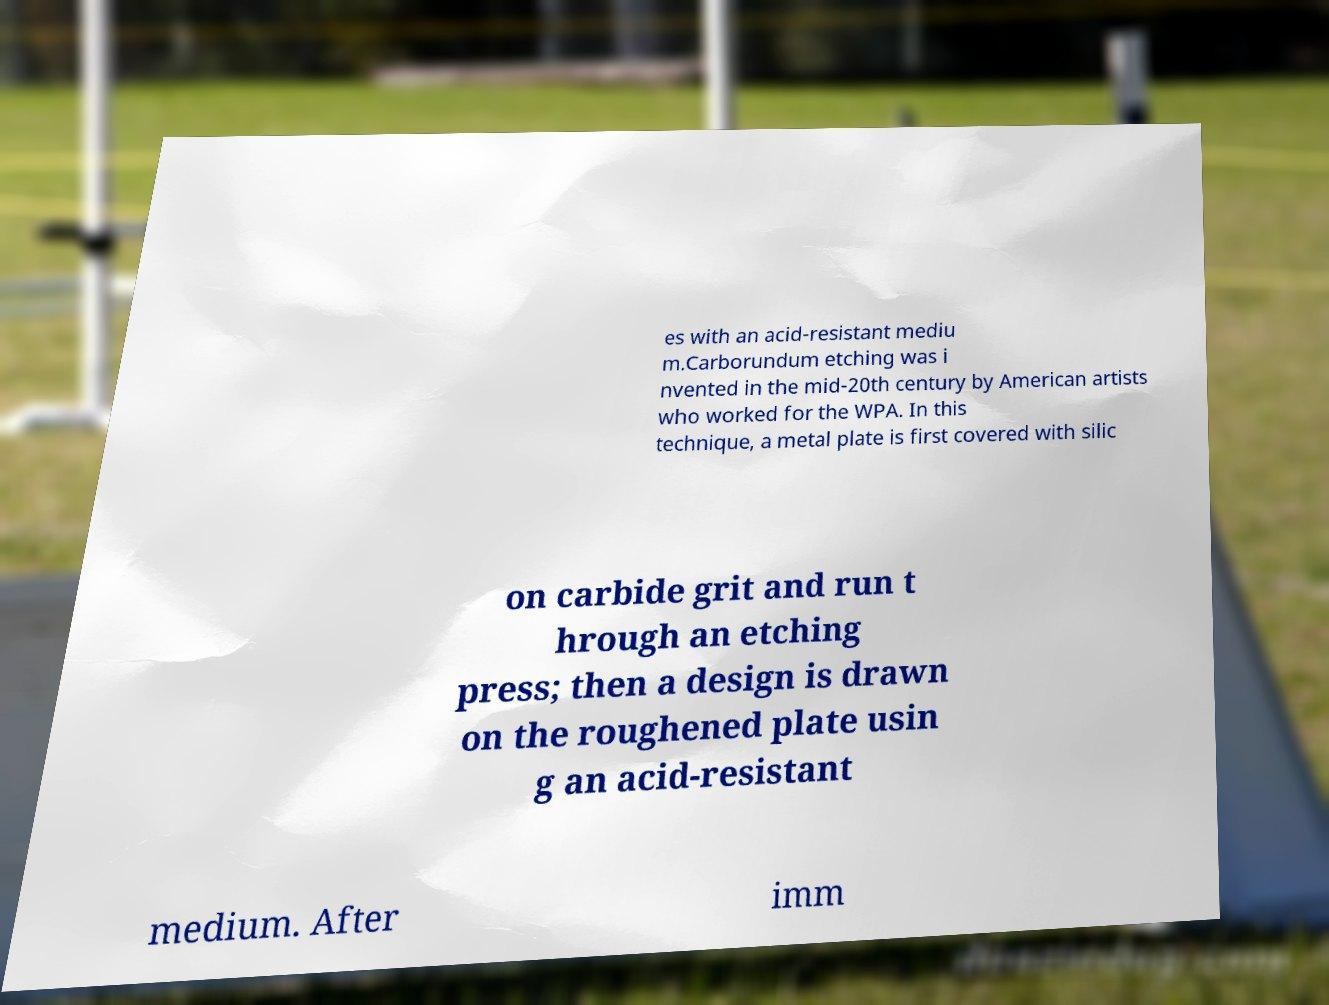What messages or text are displayed in this image? I need them in a readable, typed format. es with an acid-resistant mediu m.Carborundum etching was i nvented in the mid-20th century by American artists who worked for the WPA. In this technique, a metal plate is first covered with silic on carbide grit and run t hrough an etching press; then a design is drawn on the roughened plate usin g an acid-resistant medium. After imm 